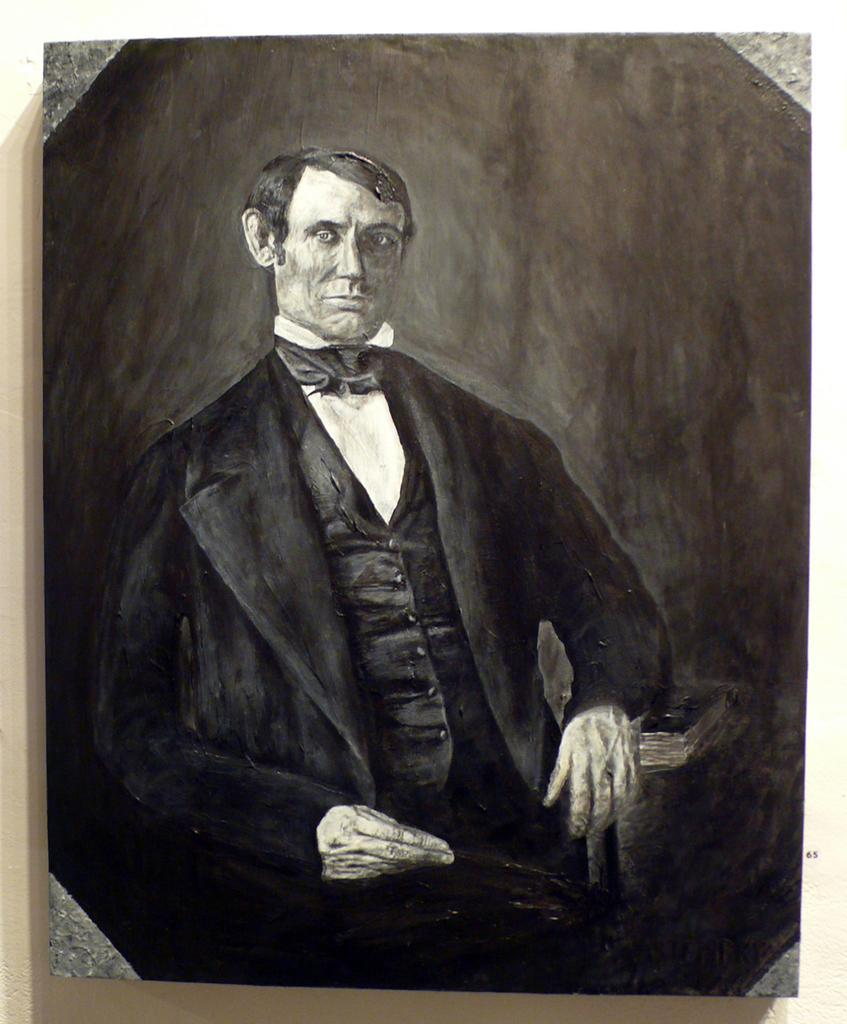What is the main subject of the image? There is a person in the image. What can be seen behind the person? There is a wall behind the person in the image. How many dolls are sitting on the wall in the image? There are no dolls present in the image; it only features a person and a wall. What type of owl can be seen perched on the person's shoulder in the image? There is no owl present in the image; it only features a person and a wall. 